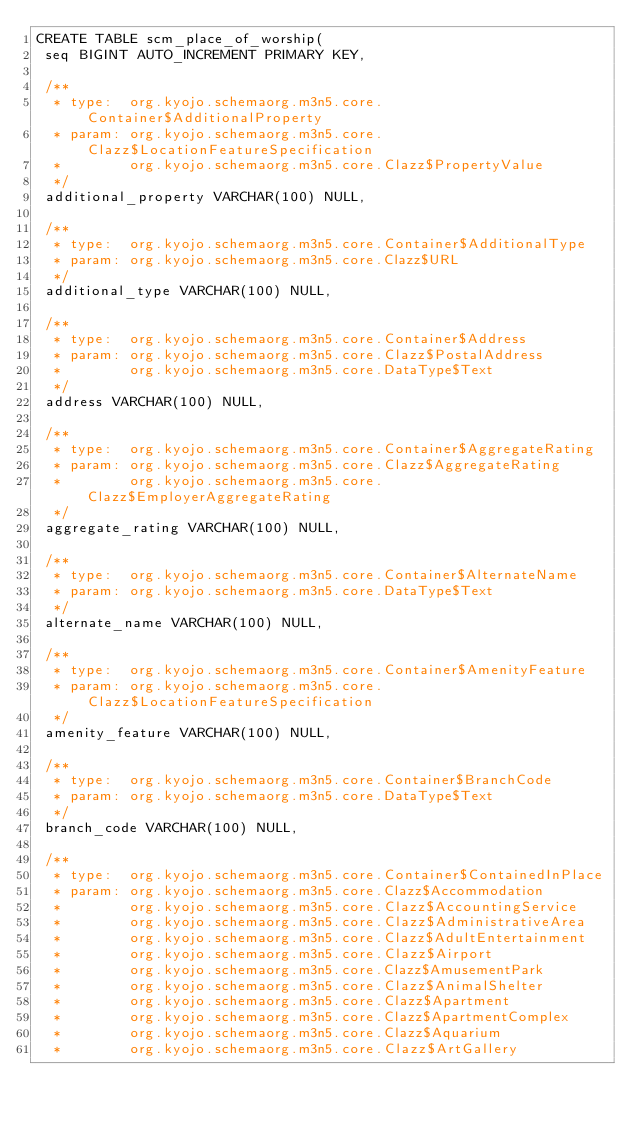<code> <loc_0><loc_0><loc_500><loc_500><_SQL_>CREATE TABLE scm_place_of_worship(
 seq BIGINT AUTO_INCREMENT PRIMARY KEY,

 /**
  * type:  org.kyojo.schemaorg.m3n5.core.Container$AdditionalProperty
  * param: org.kyojo.schemaorg.m3n5.core.Clazz$LocationFeatureSpecification
  *        org.kyojo.schemaorg.m3n5.core.Clazz$PropertyValue
  */
 additional_property VARCHAR(100) NULL,

 /**
  * type:  org.kyojo.schemaorg.m3n5.core.Container$AdditionalType
  * param: org.kyojo.schemaorg.m3n5.core.Clazz$URL
  */
 additional_type VARCHAR(100) NULL,

 /**
  * type:  org.kyojo.schemaorg.m3n5.core.Container$Address
  * param: org.kyojo.schemaorg.m3n5.core.Clazz$PostalAddress
  *        org.kyojo.schemaorg.m3n5.core.DataType$Text
  */
 address VARCHAR(100) NULL,

 /**
  * type:  org.kyojo.schemaorg.m3n5.core.Container$AggregateRating
  * param: org.kyojo.schemaorg.m3n5.core.Clazz$AggregateRating
  *        org.kyojo.schemaorg.m3n5.core.Clazz$EmployerAggregateRating
  */
 aggregate_rating VARCHAR(100) NULL,

 /**
  * type:  org.kyojo.schemaorg.m3n5.core.Container$AlternateName
  * param: org.kyojo.schemaorg.m3n5.core.DataType$Text
  */
 alternate_name VARCHAR(100) NULL,

 /**
  * type:  org.kyojo.schemaorg.m3n5.core.Container$AmenityFeature
  * param: org.kyojo.schemaorg.m3n5.core.Clazz$LocationFeatureSpecification
  */
 amenity_feature VARCHAR(100) NULL,

 /**
  * type:  org.kyojo.schemaorg.m3n5.core.Container$BranchCode
  * param: org.kyojo.schemaorg.m3n5.core.DataType$Text
  */
 branch_code VARCHAR(100) NULL,

 /**
  * type:  org.kyojo.schemaorg.m3n5.core.Container$ContainedInPlace
  * param: org.kyojo.schemaorg.m3n5.core.Clazz$Accommodation
  *        org.kyojo.schemaorg.m3n5.core.Clazz$AccountingService
  *        org.kyojo.schemaorg.m3n5.core.Clazz$AdministrativeArea
  *        org.kyojo.schemaorg.m3n5.core.Clazz$AdultEntertainment
  *        org.kyojo.schemaorg.m3n5.core.Clazz$Airport
  *        org.kyojo.schemaorg.m3n5.core.Clazz$AmusementPark
  *        org.kyojo.schemaorg.m3n5.core.Clazz$AnimalShelter
  *        org.kyojo.schemaorg.m3n5.core.Clazz$Apartment
  *        org.kyojo.schemaorg.m3n5.core.Clazz$ApartmentComplex
  *        org.kyojo.schemaorg.m3n5.core.Clazz$Aquarium
  *        org.kyojo.schemaorg.m3n5.core.Clazz$ArtGallery</code> 